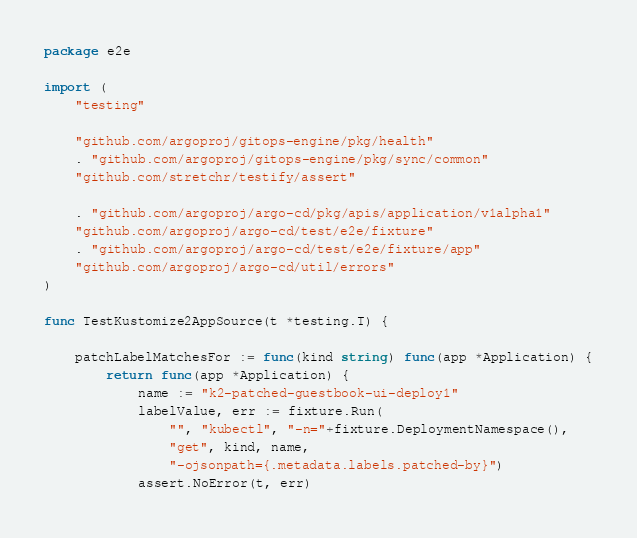Convert code to text. <code><loc_0><loc_0><loc_500><loc_500><_Go_>package e2e

import (
	"testing"

	"github.com/argoproj/gitops-engine/pkg/health"
	. "github.com/argoproj/gitops-engine/pkg/sync/common"
	"github.com/stretchr/testify/assert"

	. "github.com/argoproj/argo-cd/pkg/apis/application/v1alpha1"
	"github.com/argoproj/argo-cd/test/e2e/fixture"
	. "github.com/argoproj/argo-cd/test/e2e/fixture/app"
	"github.com/argoproj/argo-cd/util/errors"
)

func TestKustomize2AppSource(t *testing.T) {

	patchLabelMatchesFor := func(kind string) func(app *Application) {
		return func(app *Application) {
			name := "k2-patched-guestbook-ui-deploy1"
			labelValue, err := fixture.Run(
				"", "kubectl", "-n="+fixture.DeploymentNamespace(),
				"get", kind, name,
				"-ojsonpath={.metadata.labels.patched-by}")
			assert.NoError(t, err)</code> 